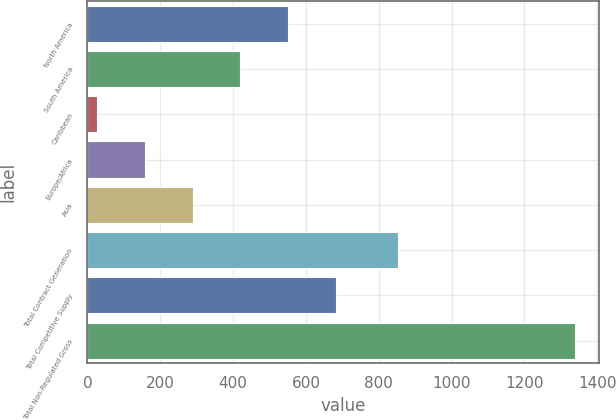Convert chart. <chart><loc_0><loc_0><loc_500><loc_500><bar_chart><fcel>North America<fcel>South America<fcel>Caribbean<fcel>Europe/Africa<fcel>Asia<fcel>Total Contract Generation<fcel>Total Competitive Supply<fcel>Total Non-Regulated Gross<nl><fcel>551.4<fcel>420.3<fcel>27<fcel>158.1<fcel>289.2<fcel>854<fcel>682.5<fcel>1338<nl></chart> 